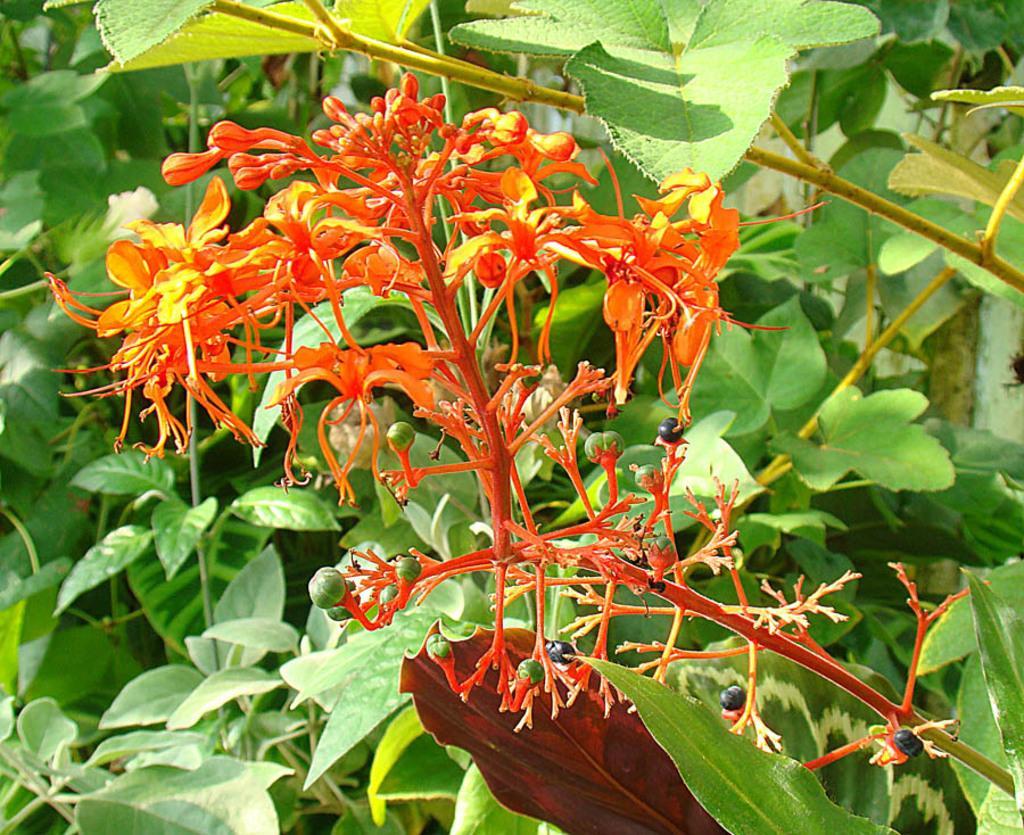Could you give a brief overview of what you see in this image? In this picture we can see flowers, buds and plants. 